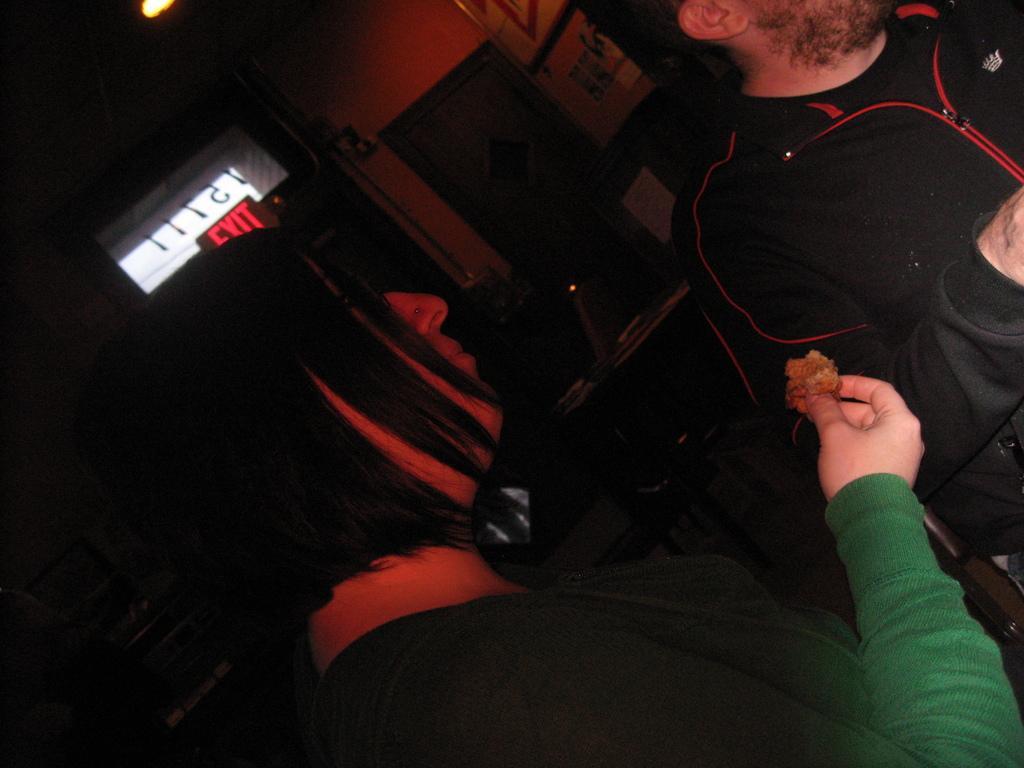Can you describe this image briefly? In this image I can see two people with green and black color dresses. I can see one person is holding the brown color item. In the background I can see the exit board and the door to the wall. I can also see the light in the top. 